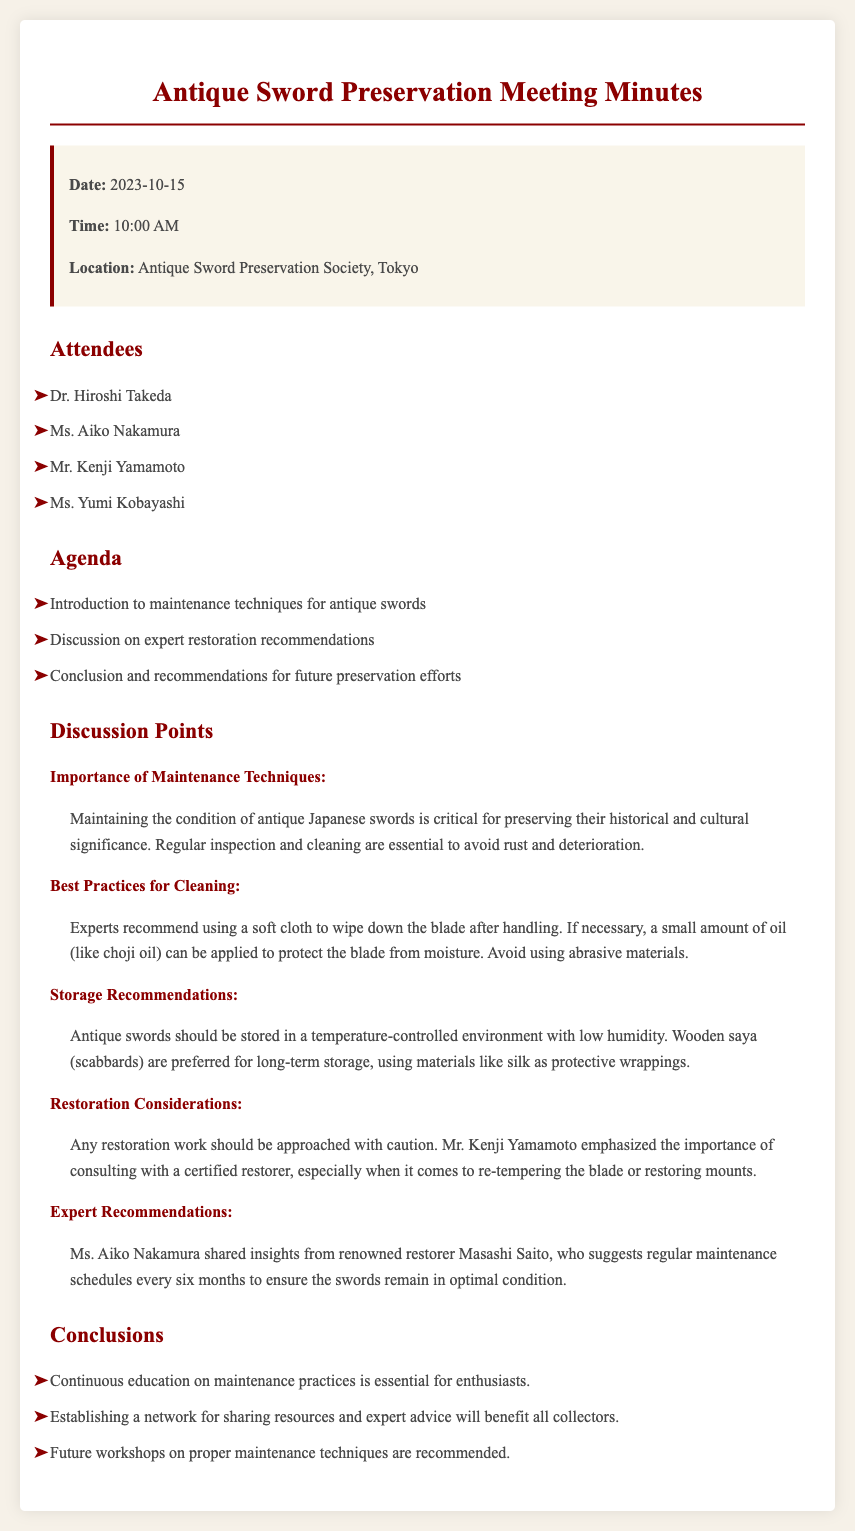What is the date of the meeting? The date of the meeting is mentioned at the beginning of the document, which is 2023-10-15.
Answer: 2023-10-15 Who emphasized the importance of consulting a certified restorer? Mr. Kenji Yamamoto's statement regarding the importance of consulting a certified restorer is noted in the discussion points.
Answer: Mr. Kenji Yamamoto What is the recommended oil for protecting the blade? The document specifies choji oil as the recommended oil for protecting the blade among the maintenance techniques.
Answer: choji oil How often should maintenance schedules be established according to expert recommendations? Ms. Aiko Nakamura mentions that regular maintenance schedules should occur every six months.
Answer: every six months What type of environment is recommended for storing antique swords? The document highlights a temperature-controlled environment with low humidity for storing antique swords.
Answer: temperature-controlled environment with low humidity What is a preferred material for protective wrappings of swords? The discussion highlights that silk is a preferred material for protective wrappings when storing swords.
Answer: silk What conclusion is drawn about future workshops? One of the conclusions states that future workshops on proper maintenance techniques are recommended.
Answer: future workshops are recommended How many attendees were present at the meeting? The document lists four individuals in the "Attendees" section, indicating the number of attendees.
Answer: four 